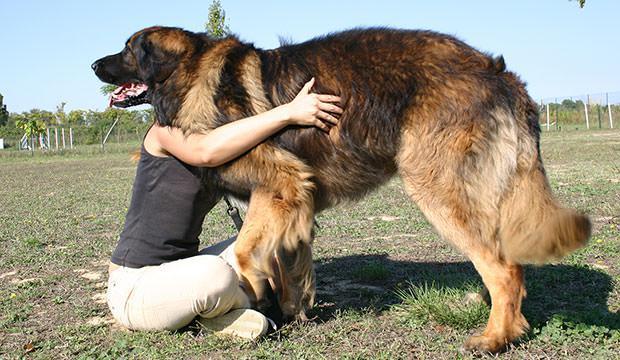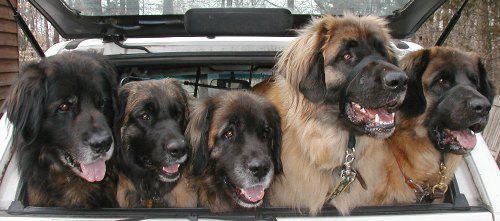The first image is the image on the left, the second image is the image on the right. Considering the images on both sides, is "At least one person is petting a dog." valid? Answer yes or no. Yes. The first image is the image on the left, the second image is the image on the right. Assess this claim about the two images: "There are exactly two dogs in the right image.". Correct or not? Answer yes or no. No. 